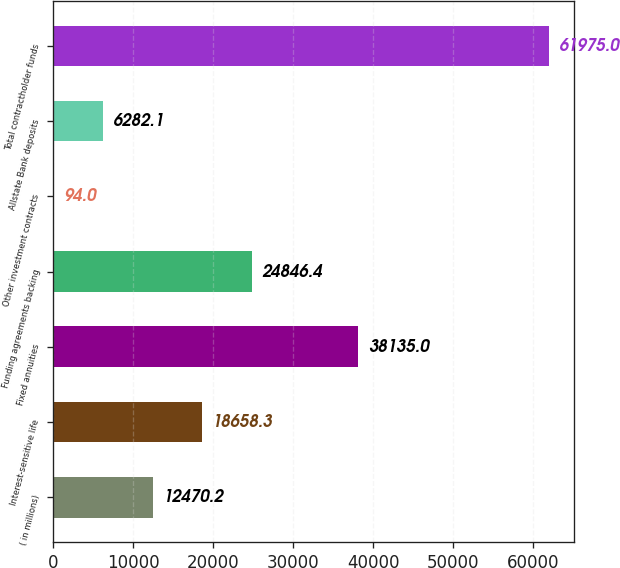Convert chart to OTSL. <chart><loc_0><loc_0><loc_500><loc_500><bar_chart><fcel>( in millions)<fcel>Interest-sensitive life<fcel>Fixed annuities<fcel>Funding agreements backing<fcel>Other investment contracts<fcel>Allstate Bank deposits<fcel>Total contractholder funds<nl><fcel>12470.2<fcel>18658.3<fcel>38135<fcel>24846.4<fcel>94<fcel>6282.1<fcel>61975<nl></chart> 